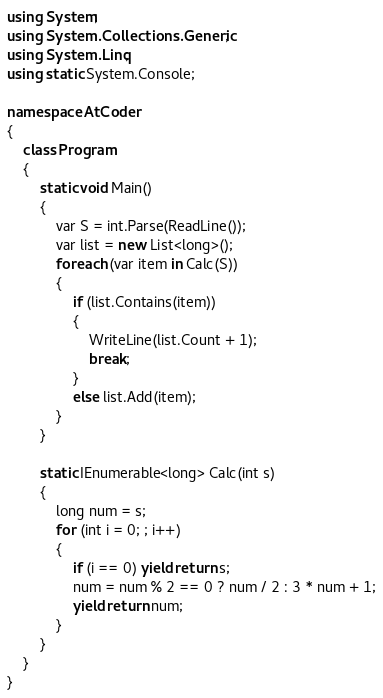Convert code to text. <code><loc_0><loc_0><loc_500><loc_500><_C#_>using System;
using System.Collections.Generic;
using System.Linq;
using static System.Console;

namespace AtCoder
{
    class Program
    {
        static void Main()
        {
            var S = int.Parse(ReadLine());
            var list = new List<long>();
            foreach (var item in Calc(S))
            {
                if (list.Contains(item))
                {
                    WriteLine(list.Count + 1);
                    break;
                }
                else list.Add(item);
            }
        }

        static IEnumerable<long> Calc(int s)
        {
            long num = s;
            for (int i = 0; ; i++)
            {
                if (i == 0) yield return s;
                num = num % 2 == 0 ? num / 2 : 3 * num + 1;
                yield return num;
            }
        }
    }
}
</code> 